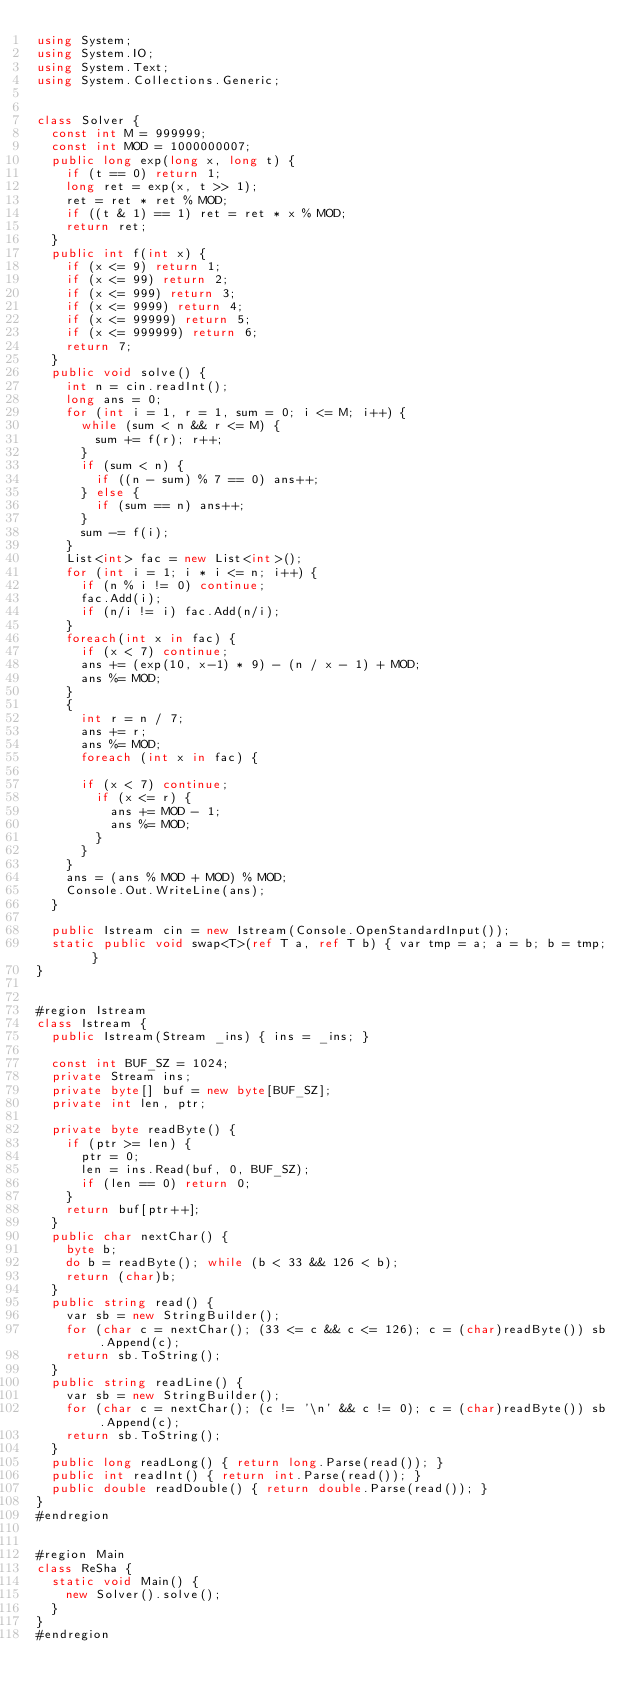Convert code to text. <code><loc_0><loc_0><loc_500><loc_500><_C#_>using System;
using System.IO;
using System.Text;
using System.Collections.Generic;


class Solver {
  const int M = 999999;
  const int MOD = 1000000007;
  public long exp(long x, long t) {
    if (t == 0) return 1;
    long ret = exp(x, t >> 1);
    ret = ret * ret % MOD;
    if ((t & 1) == 1) ret = ret * x % MOD;
    return ret;
  }
  public int f(int x) {
    if (x <= 9) return 1;
    if (x <= 99) return 2;
    if (x <= 999) return 3;
    if (x <= 9999) return 4;
    if (x <= 99999) return 5;
    if (x <= 999999) return 6;
    return 7;
  }
  public void solve() {
    int n = cin.readInt();
    long ans = 0;
    for (int i = 1, r = 1, sum = 0; i <= M; i++) {
      while (sum < n && r <= M) {
        sum += f(r); r++;
      }
      if (sum < n) {
        if ((n - sum) % 7 == 0) ans++;
      } else {
        if (sum == n) ans++;
      }
      sum -= f(i);
    }
    List<int> fac = new List<int>();
    for (int i = 1; i * i <= n; i++) {
      if (n % i != 0) continue;
      fac.Add(i);
      if (n/i != i) fac.Add(n/i);
    }
    foreach(int x in fac) {
      if (x < 7) continue;
      ans += (exp(10, x-1) * 9) - (n / x - 1) + MOD;
      ans %= MOD;
    }
    {
      int r = n / 7;
      ans += r;
      ans %= MOD;
      foreach (int x in fac) {

      if (x < 7) continue;
        if (x <= r) {
          ans += MOD - 1;
          ans %= MOD;
        }
      }
    }
    ans = (ans % MOD + MOD) % MOD;
    Console.Out.WriteLine(ans);
  }

  public Istream cin = new Istream(Console.OpenStandardInput());
  static public void swap<T>(ref T a, ref T b) { var tmp = a; a = b; b = tmp; }
}


#region Istream
class Istream {
  public Istream(Stream _ins) { ins = _ins; }

  const int BUF_SZ = 1024;
  private Stream ins;
  private byte[] buf = new byte[BUF_SZ];
  private int len, ptr;

  private byte readByte() {
    if (ptr >= len) {
      ptr = 0;
      len = ins.Read(buf, 0, BUF_SZ);
      if (len == 0) return 0;
    }
    return buf[ptr++];
  }
  public char nextChar() {
    byte b;
    do b = readByte(); while (b < 33 && 126 < b);
    return (char)b;
  }
  public string read() {
    var sb = new StringBuilder();
    for (char c = nextChar(); (33 <= c && c <= 126); c = (char)readByte()) sb.Append(c);
    return sb.ToString();
  }
  public string readLine() {
    var sb = new StringBuilder();
    for (char c = nextChar(); (c != '\n' && c != 0); c = (char)readByte()) sb.Append(c);
    return sb.ToString();
  }
  public long readLong() { return long.Parse(read()); }
  public int readInt() { return int.Parse(read()); }
  public double readDouble() { return double.Parse(read()); }
}
#endregion


#region Main
class ReSha {
  static void Main() {
    new Solver().solve();
  }
}
#endregion</code> 